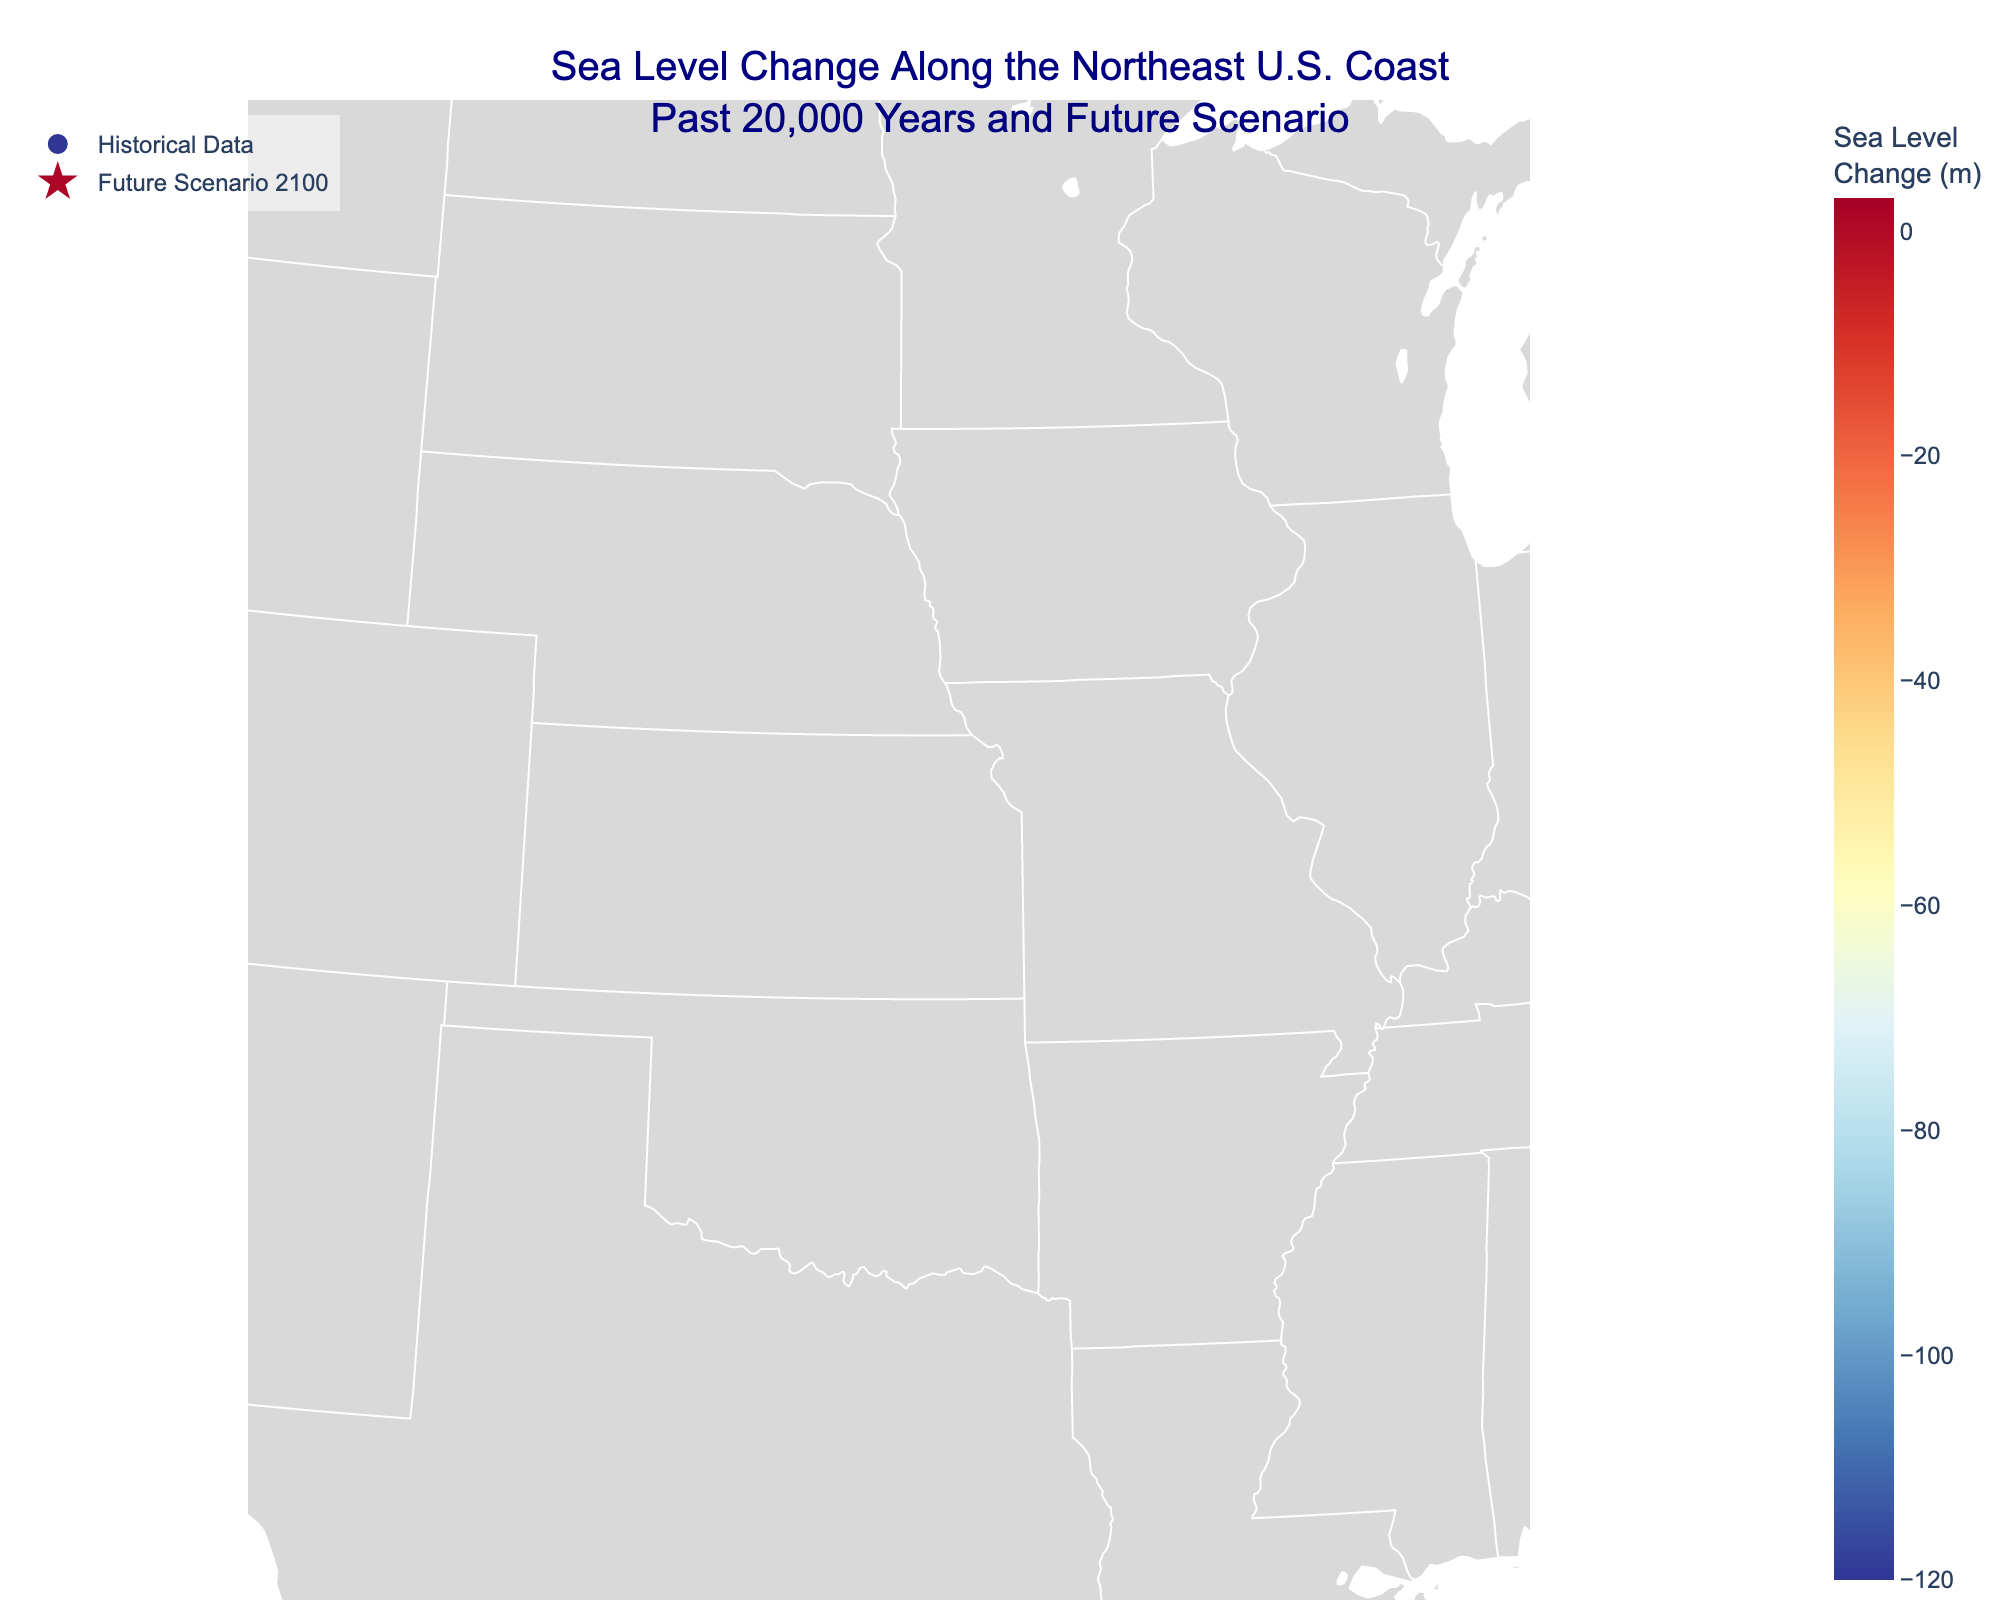What is the title of the figure? The title of the figure is stated at the top. It reads, "Sea Level Change Along the Northeast U.S. Coast Past 20,000 Years and Future Scenario."
Answer: Sea Level Change Along the Northeast U.S. Coast Past 20,000 Years and Future Scenario How many locations are represented in the plot? By counting the markers on the map representing different cities, there are 10 locations indicated.
Answer: 10 Which location shows the highest historical sea level change? By comparing the text labels of each location on the plot, Portland, ME shows the highest historical sea level change of -120 meters.
Answer: Portland, ME What is the predicted future sea level change for New York, NY in 2100? According to the text labels associated with New York, NY, the future scenario for 2100 shows a sea level change of 1.8 meters.
Answer: 1.8 m Which location has the largest predicted future sea level change? From the future scenario data represented by star markers, Savannah, GA has the largest predicted future sea level change of 3.0 meters.
Answer: Savannah, GA How has the sea level changed in Providence, RI over the past 10,000 years? By looking at Providence, RI's historical data point labeled on the map, the sea level change over the past 10,000 years is recorded as -40 meters.
Answer: -40 m Between Boston, MA and Virginia Beach, VA, which location has a larger future sea level change prediction, and by how much? Boston, MA has a future sea level prediction of 1.4 meters, while Virginia Beach, VA has 2.4 meters. Calculating the difference: 2.4 - 1.4 = 1.0 meters.
Answer: Virginia Beach, VA, by 1.0 m What is the average historical sea level change recorded across all locations? Adding all historical sea level changes: -120, -80, -40, -10, -2, -1, -0.5, -0.2, -0.1, 0 (Portland_ME to Savannah_GA), the total is -253.8. Dividing by 10 (number of locations): -253.8/10 = -25.38.
Answer: -25.38 m What are the latitude and longitude ranges shown in the map of the figure? Based on the geographic scope settings in the map, the longitude range is [-83, -68] and the latitude range is [30, 45], covering the Northeast U.S.
Answer: Longitude: [-83, -68], Latitude: [30, 45] Identify two southernmost locations in the plot and their respective future sea level change predictions. From the plot, the southernmost locations are Charleston, SC with a future scenario of 2.8 meters and Savannah, GA with 3.0 meters.
Answer: Charleston, SC: 2.8 m; Savannah, GA: 3.0 m 